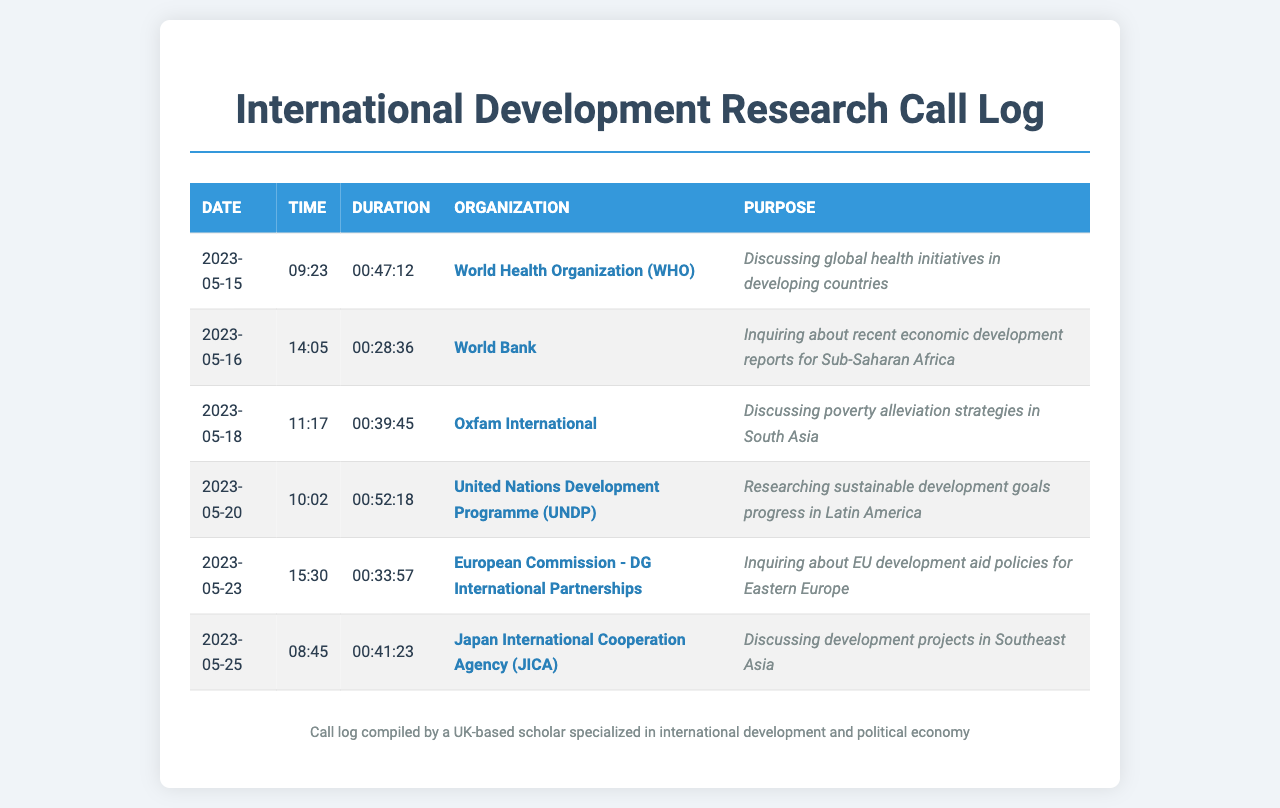What organization was called on May 15, 2023? The document lists the call logs, and on May 15, 2023, the organization called was the World Health Organization (WHO).
Answer: World Health Organization (WHO) What was the purpose of the call to Oxfam International? The document specifies that the call to Oxfam International was about discussing poverty alleviation strategies in South Asia.
Answer: Discussing poverty alleviation strategies in South Asia How long was the call made to the European Commission? The document indicates that the call to the European Commission lasted for 33 minutes and 57 seconds.
Answer: 00:33:57 Which organization was called last in the log? In the document, the last organization called on May 25, 2023, is Japan International Cooperation Agency (JICA).
Answer: Japan International Cooperation Agency (JICA) On what date was the call to the United Nations Development Programme? According to the document, the call to the United Nations Development Programme occurred on May 20, 2023.
Answer: 2023-05-20 What was the focus of the inquiry to the World Bank? The document states that the inquiry to the World Bank was about recent economic development reports for Sub-Saharan Africa.
Answer: Recent economic development reports for Sub-Saharan Africa How many organizations were contacted in total? The document lists six distinct organizations in the call log.
Answer: 6 Which two organizations were contacted for discussions on development strategies? The document shows that the discussions on development strategies were with Oxfam International and the United Nations Development Programme (UNDP).
Answer: Oxfam International and United Nations Development Programme (UNDP) 